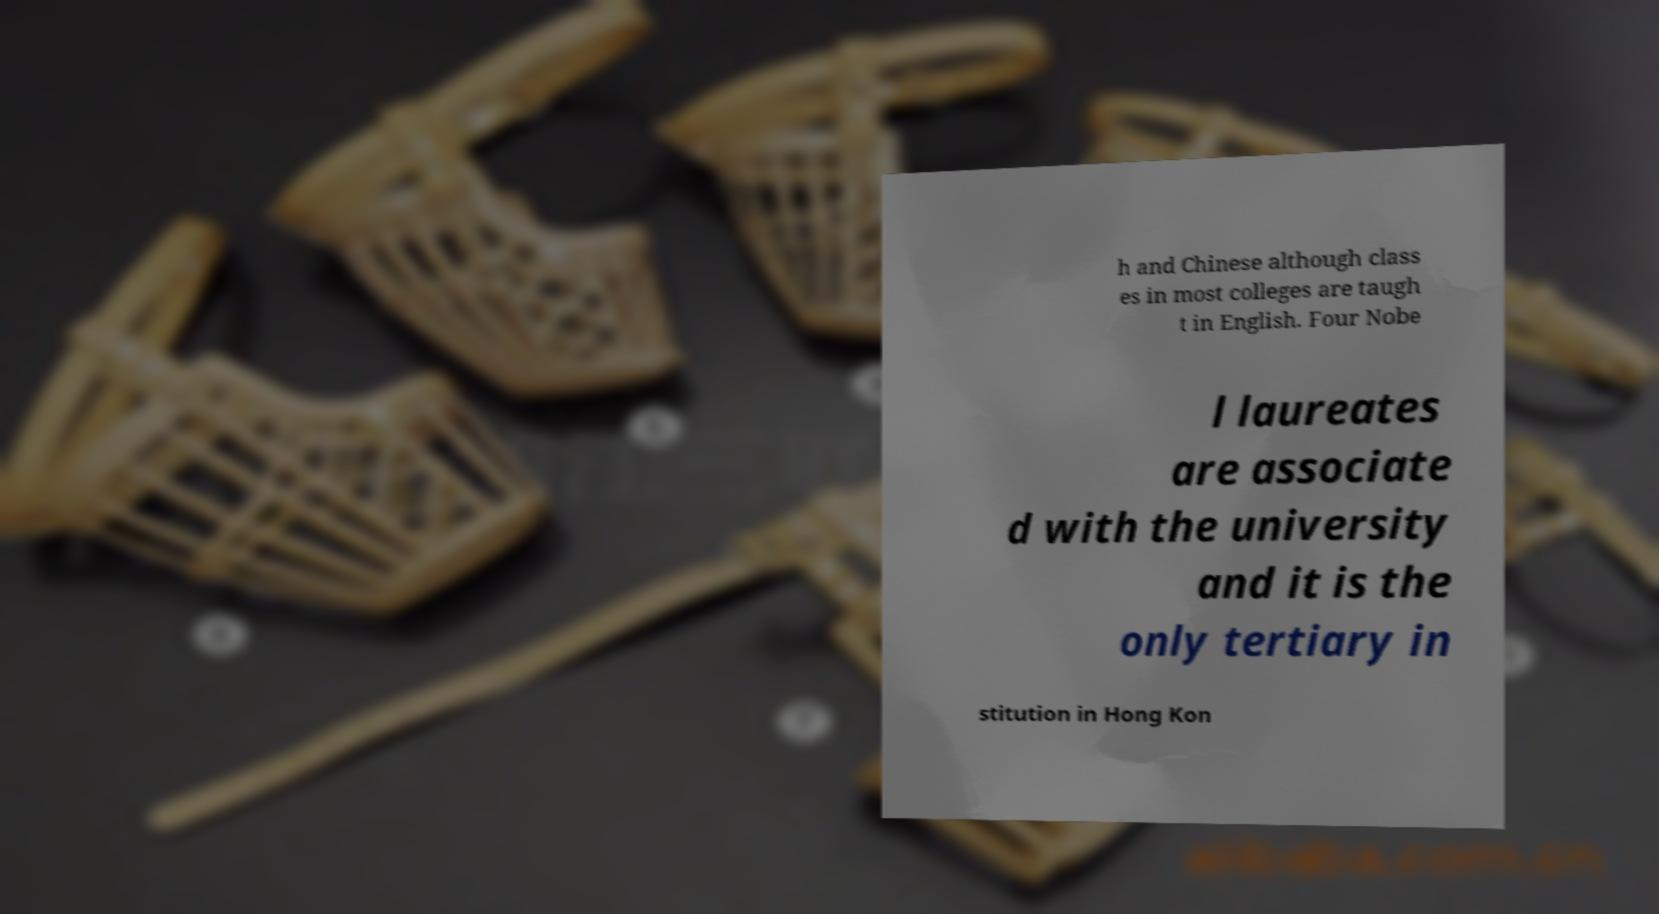Can you accurately transcribe the text from the provided image for me? h and Chinese although class es in most colleges are taugh t in English. Four Nobe l laureates are associate d with the university and it is the only tertiary in stitution in Hong Kon 